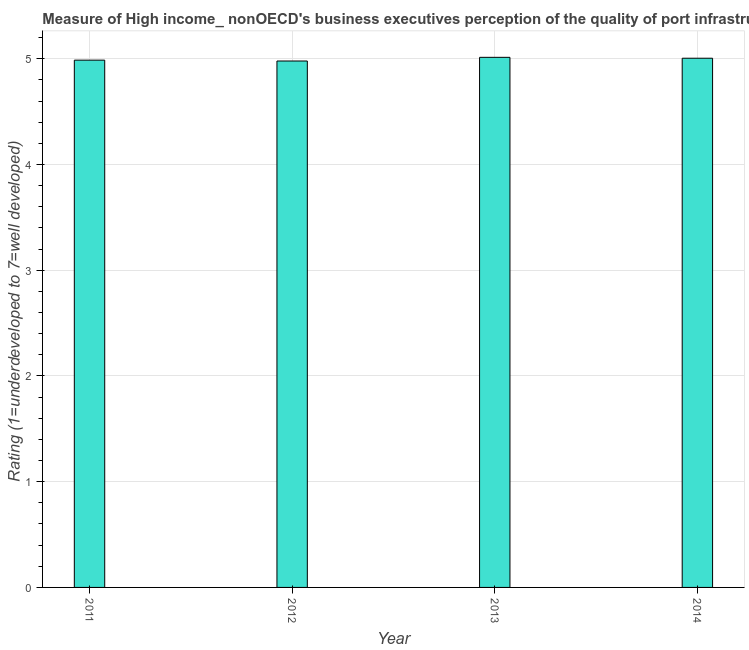Does the graph contain grids?
Your answer should be compact. Yes. What is the title of the graph?
Offer a very short reply. Measure of High income_ nonOECD's business executives perception of the quality of port infrastructure. What is the label or title of the X-axis?
Ensure brevity in your answer.  Year. What is the label or title of the Y-axis?
Ensure brevity in your answer.  Rating (1=underdeveloped to 7=well developed) . What is the rating measuring quality of port infrastructure in 2012?
Keep it short and to the point. 4.98. Across all years, what is the maximum rating measuring quality of port infrastructure?
Your answer should be very brief. 5.01. Across all years, what is the minimum rating measuring quality of port infrastructure?
Keep it short and to the point. 4.98. In which year was the rating measuring quality of port infrastructure maximum?
Offer a terse response. 2013. What is the sum of the rating measuring quality of port infrastructure?
Offer a terse response. 19.98. What is the difference between the rating measuring quality of port infrastructure in 2012 and 2013?
Ensure brevity in your answer.  -0.04. What is the average rating measuring quality of port infrastructure per year?
Give a very brief answer. 5. What is the median rating measuring quality of port infrastructure?
Keep it short and to the point. 5. In how many years, is the rating measuring quality of port infrastructure greater than 2.2 ?
Offer a very short reply. 4. Do a majority of the years between 2013 and 2012 (inclusive) have rating measuring quality of port infrastructure greater than 1.4 ?
Provide a short and direct response. No. What is the difference between the highest and the second highest rating measuring quality of port infrastructure?
Offer a very short reply. 0.01. Is the sum of the rating measuring quality of port infrastructure in 2011 and 2014 greater than the maximum rating measuring quality of port infrastructure across all years?
Ensure brevity in your answer.  Yes. What is the difference between the highest and the lowest rating measuring quality of port infrastructure?
Ensure brevity in your answer.  0.03. What is the difference between two consecutive major ticks on the Y-axis?
Provide a short and direct response. 1. Are the values on the major ticks of Y-axis written in scientific E-notation?
Provide a succinct answer. No. What is the Rating (1=underdeveloped to 7=well developed)  in 2011?
Offer a very short reply. 4.99. What is the Rating (1=underdeveloped to 7=well developed)  in 2012?
Keep it short and to the point. 4.98. What is the Rating (1=underdeveloped to 7=well developed)  of 2013?
Keep it short and to the point. 5.01. What is the Rating (1=underdeveloped to 7=well developed)  in 2014?
Your response must be concise. 5. What is the difference between the Rating (1=underdeveloped to 7=well developed)  in 2011 and 2012?
Offer a terse response. 0.01. What is the difference between the Rating (1=underdeveloped to 7=well developed)  in 2011 and 2013?
Provide a short and direct response. -0.03. What is the difference between the Rating (1=underdeveloped to 7=well developed)  in 2011 and 2014?
Your response must be concise. -0.02. What is the difference between the Rating (1=underdeveloped to 7=well developed)  in 2012 and 2013?
Give a very brief answer. -0.03. What is the difference between the Rating (1=underdeveloped to 7=well developed)  in 2012 and 2014?
Your answer should be very brief. -0.03. What is the difference between the Rating (1=underdeveloped to 7=well developed)  in 2013 and 2014?
Keep it short and to the point. 0.01. What is the ratio of the Rating (1=underdeveloped to 7=well developed)  in 2011 to that in 2014?
Make the answer very short. 1. What is the ratio of the Rating (1=underdeveloped to 7=well developed)  in 2012 to that in 2013?
Give a very brief answer. 0.99. What is the ratio of the Rating (1=underdeveloped to 7=well developed)  in 2012 to that in 2014?
Keep it short and to the point. 0.99. 